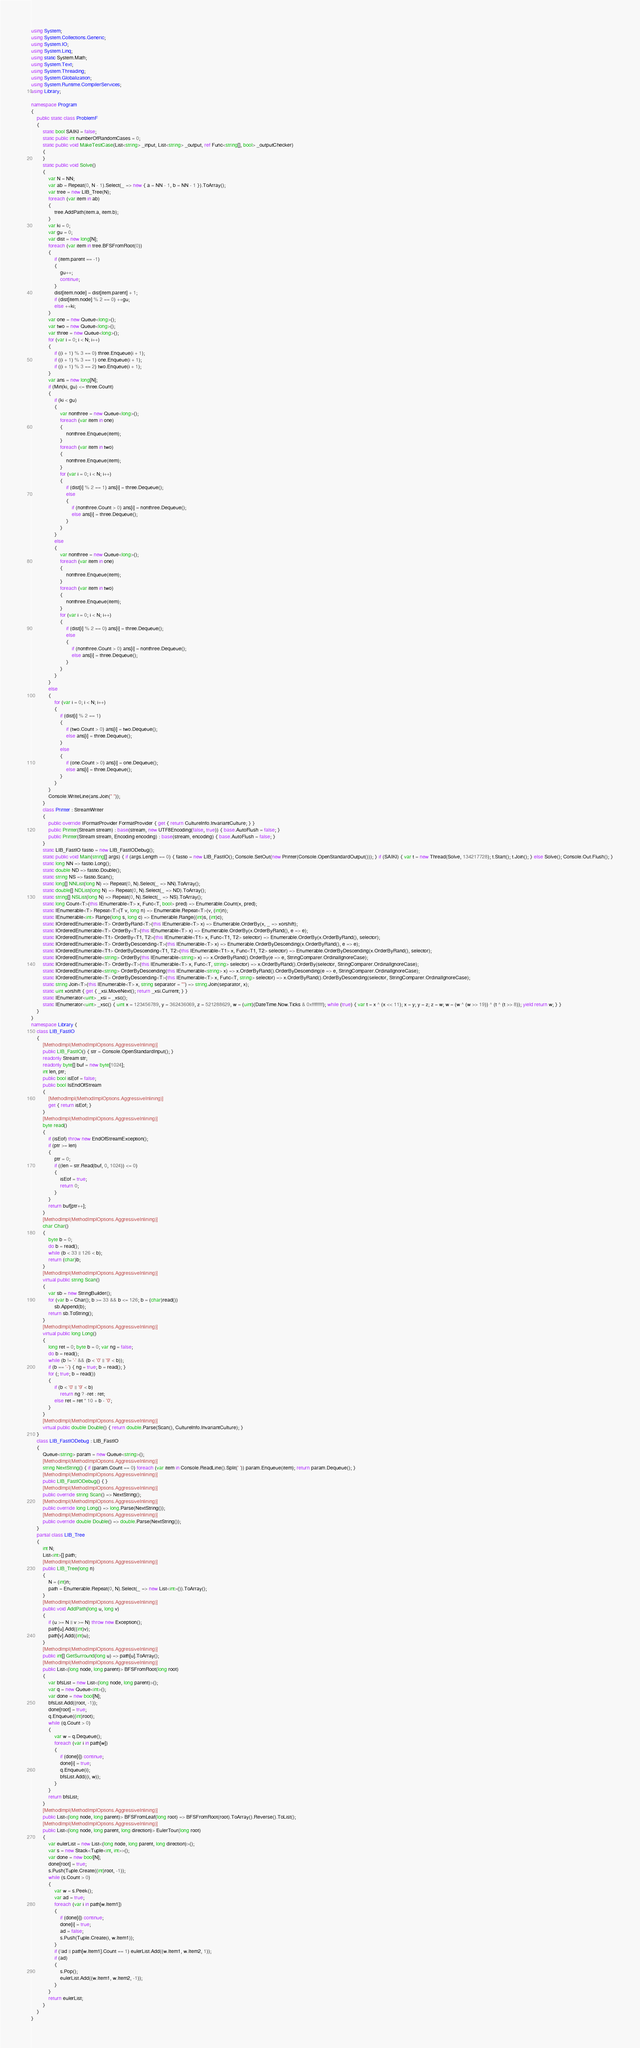<code> <loc_0><loc_0><loc_500><loc_500><_C#_>using System;
using System.Collections.Generic;
using System.IO;
using System.Linq;
using static System.Math;
using System.Text;
using System.Threading;
using System.Globalization;
using System.Runtime.CompilerServices;
using Library;

namespace Program
{
    public static class ProblemF
    {
        static bool SAIKI = false;
        static public int numberOfRandomCases = 0;
        static public void MakeTestCase(List<string> _input, List<string> _output, ref Func<string[], bool> _outputChecker)
        {
        }
        static public void Solve()
        {
            var N = NN;
            var ab = Repeat(0, N - 1).Select(_ => new { a = NN - 1, b = NN - 1 }).ToArray();
            var tree = new LIB_Tree(N);
            foreach (var item in ab)
            {
                tree.AddPath(item.a, item.b);
            }
            var ki = 0;
            var gu = 0;
            var dist = new long[N];
            foreach (var item in tree.BFSFromRoot(0))
            {
                if (item.parent == -1)
                {
                    gu++;
                    continue;
                }
                dist[item.node] = dist[item.parent] + 1;
                if (dist[item.node] % 2 == 0) ++gu;
                else ++ki;
            }
            var one = new Queue<long>();
            var two = new Queue<long>();
            var three = new Queue<long>();
            for (var i = 0; i < N; i++)
            {
                if ((i + 1) % 3 == 0) three.Enqueue(i + 1);
                if ((i + 1) % 3 == 1) one.Enqueue(i + 1);
                if ((i + 1) % 3 == 2) two.Enqueue(i + 1);
            }
            var ans = new long[N];
            if (Min(ki, gu) <= three.Count)
            {
                if (ki < gu)
                {
                    var nonthree = new Queue<long>();
                    foreach (var item in one)
                    {
                        nonthree.Enqueue(item);
                    }
                    foreach (var item in two)
                    {
                        nonthree.Enqueue(item);
                    }
                    for (var i = 0; i < N; i++)
                    {
                        if (dist[i] % 2 == 1) ans[i] = three.Dequeue();
                        else
                        {
                            if (nonthree.Count > 0) ans[i] = nonthree.Dequeue();
                            else ans[i] = three.Dequeue();
                        }
                    }
                }
                else
                {
                    var nonthree = new Queue<long>();
                    foreach (var item in one)
                    {
                        nonthree.Enqueue(item);
                    }
                    foreach (var item in two)
                    {
                        nonthree.Enqueue(item);
                    }
                    for (var i = 0; i < N; i++)
                    {
                        if (dist[i] % 2 == 0) ans[i] = three.Dequeue();
                        else
                        {
                            if (nonthree.Count > 0) ans[i] = nonthree.Dequeue();
                            else ans[i] = three.Dequeue();
                        }
                    }
                }
            }
            else
            {
                for (var i = 0; i < N; i++)
                {
                    if (dist[i] % 2 == 1)
                    {
                        if (two.Count > 0) ans[i] = two.Dequeue();
                        else ans[i] = three.Dequeue();
                    }
                    else
                    {
                        if (one.Count > 0) ans[i] = one.Dequeue();
                        else ans[i] = three.Dequeue();
                    }
                }
            }
            Console.WriteLine(ans.Join(" "));
        }
        class Printer : StreamWriter
        {
            public override IFormatProvider FormatProvider { get { return CultureInfo.InvariantCulture; } }
            public Printer(Stream stream) : base(stream, new UTF8Encoding(false, true)) { base.AutoFlush = false; }
            public Printer(Stream stream, Encoding encoding) : base(stream, encoding) { base.AutoFlush = false; }
        }
        static LIB_FastIO fastio = new LIB_FastIODebug();
        static public void Main(string[] args) { if (args.Length == 0) { fastio = new LIB_FastIO(); Console.SetOut(new Printer(Console.OpenStandardOutput())); } if (SAIKI) { var t = new Thread(Solve, 134217728); t.Start(); t.Join(); } else Solve(); Console.Out.Flush(); }
        static long NN => fastio.Long();
        static double ND => fastio.Double();
        static string NS => fastio.Scan();
        static long[] NNList(long N) => Repeat(0, N).Select(_ => NN).ToArray();
        static double[] NDList(long N) => Repeat(0, N).Select(_ => ND).ToArray();
        static string[] NSList(long N) => Repeat(0, N).Select(_ => NS).ToArray();
        static long Count<T>(this IEnumerable<T> x, Func<T, bool> pred) => Enumerable.Count(x, pred);
        static IEnumerable<T> Repeat<T>(T v, long n) => Enumerable.Repeat<T>(v, (int)n);
        static IEnumerable<int> Range(long s, long c) => Enumerable.Range((int)s, (int)c);
        static IOrderedEnumerable<T> OrderByRand<T>(this IEnumerable<T> x) => Enumerable.OrderBy(x, _ => xorshift);
        static IOrderedEnumerable<T> OrderBy<T>(this IEnumerable<T> x) => Enumerable.OrderBy(x.OrderByRand(), e => e);
        static IOrderedEnumerable<T1> OrderBy<T1, T2>(this IEnumerable<T1> x, Func<T1, T2> selector) => Enumerable.OrderBy(x.OrderByRand(), selector);
        static IOrderedEnumerable<T> OrderByDescending<T>(this IEnumerable<T> x) => Enumerable.OrderByDescending(x.OrderByRand(), e => e);
        static IOrderedEnumerable<T1> OrderByDescending<T1, T2>(this IEnumerable<T1> x, Func<T1, T2> selector) => Enumerable.OrderByDescending(x.OrderByRand(), selector);
        static IOrderedEnumerable<string> OrderBy(this IEnumerable<string> x) => x.OrderByRand().OrderBy(e => e, StringComparer.OrdinalIgnoreCase);
        static IOrderedEnumerable<T> OrderBy<T>(this IEnumerable<T> x, Func<T, string> selector) => x.OrderByRand().OrderBy(selector, StringComparer.OrdinalIgnoreCase);
        static IOrderedEnumerable<string> OrderByDescending(this IEnumerable<string> x) => x.OrderByRand().OrderByDescending(e => e, StringComparer.OrdinalIgnoreCase);
        static IOrderedEnumerable<T> OrderByDescending<T>(this IEnumerable<T> x, Func<T, string> selector) => x.OrderByRand().OrderByDescending(selector, StringComparer.OrdinalIgnoreCase);
        static string Join<T>(this IEnumerable<T> x, string separator = "") => string.Join(separator, x);
        static uint xorshift { get { _xsi.MoveNext(); return _xsi.Current; } }
        static IEnumerator<uint> _xsi = _xsc();
        static IEnumerator<uint> _xsc() { uint x = 123456789, y = 362436069, z = 521288629, w = (uint)(DateTime.Now.Ticks & 0xffffffff); while (true) { var t = x ^ (x << 11); x = y; y = z; z = w; w = (w ^ (w >> 19)) ^ (t ^ (t >> 8)); yield return w; } }
    }
}
namespace Library {
    class LIB_FastIO
    {
        [MethodImpl(MethodImplOptions.AggressiveInlining)]
        public LIB_FastIO() { str = Console.OpenStandardInput(); }
        readonly Stream str;
        readonly byte[] buf = new byte[1024];
        int len, ptr;
        public bool isEof = false;
        public bool IsEndOfStream
        {
            [MethodImpl(MethodImplOptions.AggressiveInlining)]
            get { return isEof; }
        }
        [MethodImpl(MethodImplOptions.AggressiveInlining)]
        byte read()
        {
            if (isEof) throw new EndOfStreamException();
            if (ptr >= len)
            {
                ptr = 0;
                if ((len = str.Read(buf, 0, 1024)) <= 0)
                {
                    isEof = true;
                    return 0;
                }
            }
            return buf[ptr++];
        }
        [MethodImpl(MethodImplOptions.AggressiveInlining)]
        char Char()
        {
            byte b = 0;
            do b = read();
            while (b < 33 || 126 < b);
            return (char)b;
        }
        [MethodImpl(MethodImplOptions.AggressiveInlining)]
        virtual public string Scan()
        {
            var sb = new StringBuilder();
            for (var b = Char(); b >= 33 && b <= 126; b = (char)read())
                sb.Append(b);
            return sb.ToString();
        }
        [MethodImpl(MethodImplOptions.AggressiveInlining)]
        virtual public long Long()
        {
            long ret = 0; byte b = 0; var ng = false;
            do b = read();
            while (b != '-' && (b < '0' || '9' < b));
            if (b == '-') { ng = true; b = read(); }
            for (; true; b = read())
            {
                if (b < '0' || '9' < b)
                    return ng ? -ret : ret;
                else ret = ret * 10 + b - '0';
            }
        }
        [MethodImpl(MethodImplOptions.AggressiveInlining)]
        virtual public double Double() { return double.Parse(Scan(), CultureInfo.InvariantCulture); }
    }
    class LIB_FastIODebug : LIB_FastIO
    {
        Queue<string> param = new Queue<string>();
        [MethodImpl(MethodImplOptions.AggressiveInlining)]
        string NextString() { if (param.Count == 0) foreach (var item in Console.ReadLine().Split(' ')) param.Enqueue(item); return param.Dequeue(); }
        [MethodImpl(MethodImplOptions.AggressiveInlining)]
        public LIB_FastIODebug() { }
        [MethodImpl(MethodImplOptions.AggressiveInlining)]
        public override string Scan() => NextString();
        [MethodImpl(MethodImplOptions.AggressiveInlining)]
        public override long Long() => long.Parse(NextString());
        [MethodImpl(MethodImplOptions.AggressiveInlining)]
        public override double Double() => double.Parse(NextString());
    }
    partial class LIB_Tree
    {
        int N;
        List<int>[] path;
        [MethodImpl(MethodImplOptions.AggressiveInlining)]
        public LIB_Tree(long n)
        {
            N = (int)n;
            path = Enumerable.Repeat(0, N).Select(_ => new List<int>()).ToArray();
        }
        [MethodImpl(MethodImplOptions.AggressiveInlining)]
        public void AddPath(long u, long v)
        {
            if (u >= N || v >= N) throw new Exception();
            path[u].Add((int)v);
            path[v].Add((int)u);
        }
        [MethodImpl(MethodImplOptions.AggressiveInlining)]
        public int[] GetSurround(long u) => path[u].ToArray();
        [MethodImpl(MethodImplOptions.AggressiveInlining)]
        public List<(long node, long parent)> BFSFromRoot(long root)
        {
            var bfsList = new List<(long node, long parent)>();
            var q = new Queue<int>();
            var done = new bool[N];
            bfsList.Add((root, -1));
            done[root] = true;
            q.Enqueue((int)root);
            while (q.Count > 0)
            {
                var w = q.Dequeue();
                foreach (var i in path[w])
                {
                    if (done[i]) continue;
                    done[i] = true;
                    q.Enqueue(i);
                    bfsList.Add((i, w));
                }
            }
            return bfsList;
        }
        [MethodImpl(MethodImplOptions.AggressiveInlining)]
        public List<(long node, long parent)> BFSFromLeaf(long root) => BFSFromRoot(root).ToArray().Reverse().ToList();
        [MethodImpl(MethodImplOptions.AggressiveInlining)]
        public List<(long node, long parent, long direction)> EulerTour(long root)
        {
            var eulerList = new List<(long node, long parent, long direction)>();
            var s = new Stack<Tuple<int, int>>();
            var done = new bool[N];
            done[root] = true;
            s.Push(Tuple.Create((int)root, -1));
            while (s.Count > 0)
            {
                var w = s.Peek();
                var ad = true;
                foreach (var i in path[w.Item1])
                {
                    if (done[i]) continue;
                    done[i] = true;
                    ad = false;
                    s.Push(Tuple.Create(i, w.Item1));
                }
                if (!ad || path[w.Item1].Count == 1) eulerList.Add((w.Item1, w.Item2, 1));
                if (ad)
                {
                    s.Pop();
                    eulerList.Add((w.Item1, w.Item2, -1));
                }
            }
            return eulerList;
        }
    }
}
</code> 